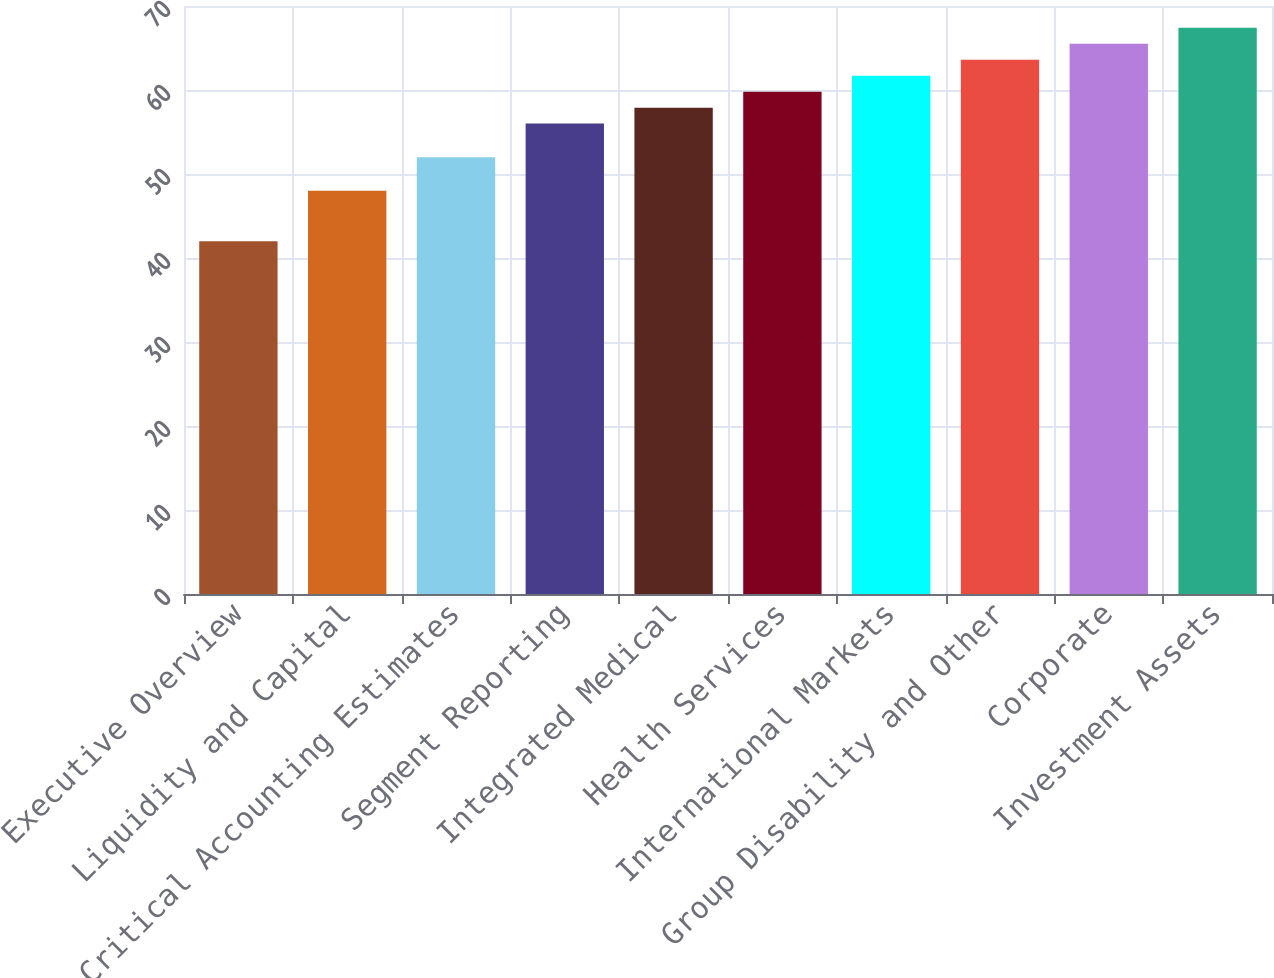<chart> <loc_0><loc_0><loc_500><loc_500><bar_chart><fcel>Executive Overview<fcel>Liquidity and Capital<fcel>Critical Accounting Estimates<fcel>Segment Reporting<fcel>Integrated Medical<fcel>Health Services<fcel>International Markets<fcel>Group Disability and Other<fcel>Corporate<fcel>Investment Assets<nl><fcel>42<fcel>48<fcel>52<fcel>56<fcel>57.9<fcel>59.8<fcel>61.7<fcel>63.6<fcel>65.5<fcel>67.4<nl></chart> 